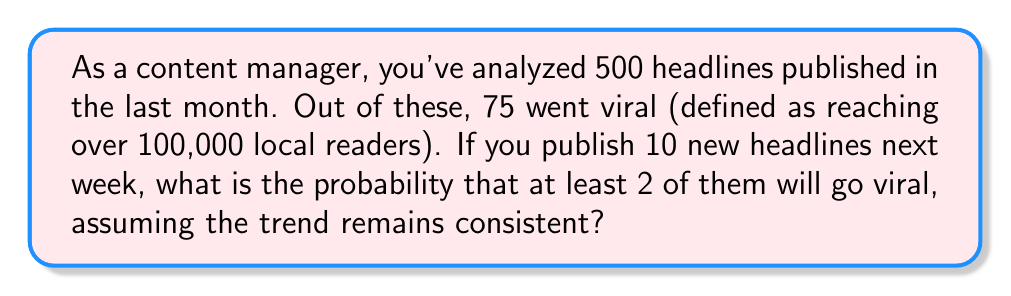Can you solve this math problem? Let's approach this step-by-step:

1) First, we need to calculate the probability of a single headline going viral:
   $p = \frac{75}{500} = 0.15$ or 15%

2) The probability of a headline not going viral is:
   $q = 1 - p = 1 - 0.15 = 0.85$ or 85%

3) We want to find the probability of at least 2 out of 10 headlines going viral. It's easier to calculate the probability of 0 or 1 headline going viral and subtract from 1:

   $P(\text{at least 2 viral}) = 1 - P(0 \text{ viral}) - P(1 \text{ viral})$

4) This follows a binomial distribution. The probability of exactly $k$ successes in $n$ trials is:

   $P(X = k) = \binom{n}{k} p^k q^{n-k}$

5) For 0 viral headlines:
   $P(0 \text{ viral}) = \binom{10}{0} 0.15^0 0.85^{10} = 0.85^{10} \approx 0.1968$

6) For 1 viral headline:
   $P(1 \text{ viral}) = \binom{10}{1} 0.15^1 0.85^9 = 10 \cdot 0.15 \cdot 0.85^9 \approx 0.3474$

7) Therefore, the probability of at least 2 viral headlines is:
   $P(\text{at least 2 viral}) = 1 - 0.1968 - 0.3474 = 0.4558$
Answer: $$0.4558$$ or $$45.58\%$$ 